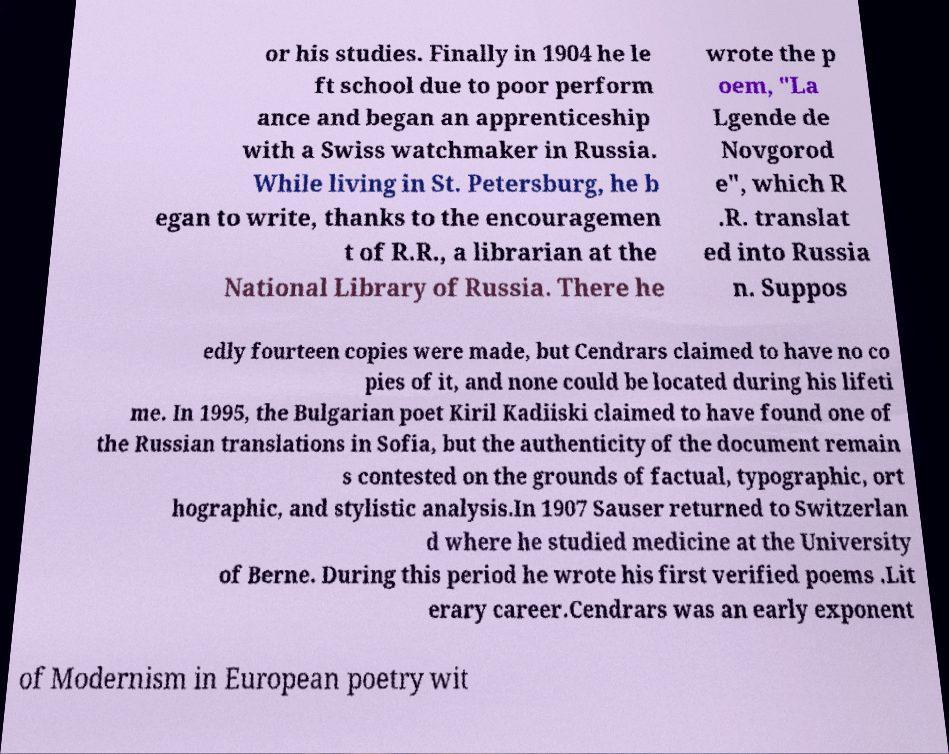What messages or text are displayed in this image? I need them in a readable, typed format. or his studies. Finally in 1904 he le ft school due to poor perform ance and began an apprenticeship with a Swiss watchmaker in Russia. While living in St. Petersburg, he b egan to write, thanks to the encouragemen t of R.R., a librarian at the National Library of Russia. There he wrote the p oem, "La Lgende de Novgorod e", which R .R. translat ed into Russia n. Suppos edly fourteen copies were made, but Cendrars claimed to have no co pies of it, and none could be located during his lifeti me. In 1995, the Bulgarian poet Kiril Kadiiski claimed to have found one of the Russian translations in Sofia, but the authenticity of the document remain s contested on the grounds of factual, typographic, ort hographic, and stylistic analysis.In 1907 Sauser returned to Switzerlan d where he studied medicine at the University of Berne. During this period he wrote his first verified poems .Lit erary career.Cendrars was an early exponent of Modernism in European poetry wit 